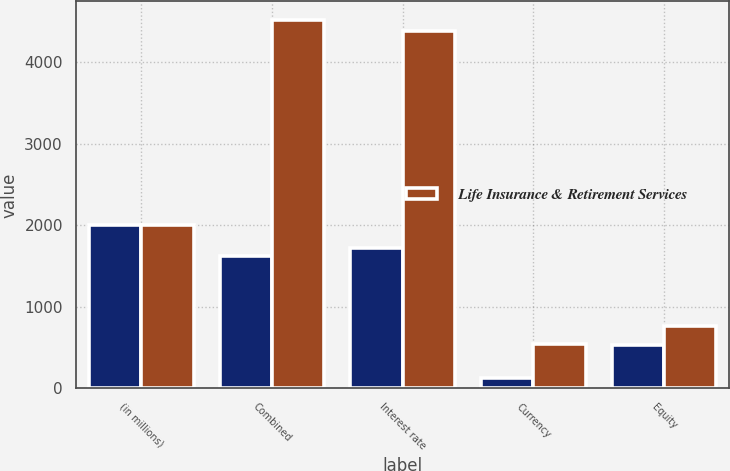Convert chart to OTSL. <chart><loc_0><loc_0><loc_500><loc_500><stacked_bar_chart><ecel><fcel>(in millions)<fcel>Combined<fcel>Interest rate<fcel>Currency<fcel>Equity<nl><fcel>nan<fcel>2005<fcel>1617<fcel>1717<fcel>130<fcel>535<nl><fcel>Life Insurance & Retirement Services<fcel>2005<fcel>4515<fcel>4382<fcel>541<fcel>762<nl></chart> 